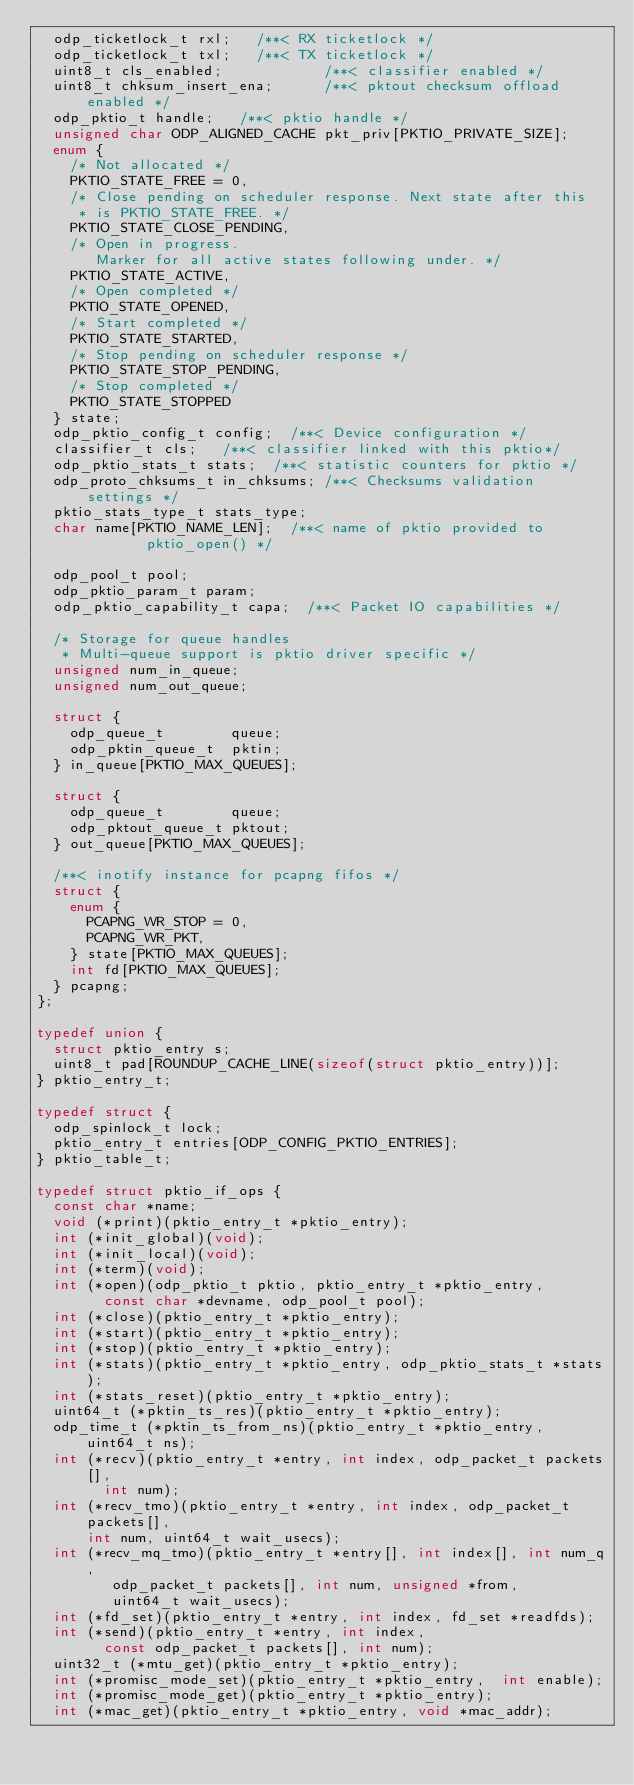<code> <loc_0><loc_0><loc_500><loc_500><_C_>	odp_ticketlock_t rxl;		/**< RX ticketlock */
	odp_ticketlock_t txl;		/**< TX ticketlock */
	uint8_t cls_enabled;            /**< classifier enabled */
	uint8_t chksum_insert_ena;      /**< pktout checksum offload enabled */
	odp_pktio_t handle;		/**< pktio handle */
	unsigned char ODP_ALIGNED_CACHE pkt_priv[PKTIO_PRIVATE_SIZE];
	enum {
		/* Not allocated */
		PKTIO_STATE_FREE = 0,
		/* Close pending on scheduler response. Next state after this
		 * is PKTIO_STATE_FREE. */
		PKTIO_STATE_CLOSE_PENDING,
		/* Open in progress.
		   Marker for all active states following under. */
		PKTIO_STATE_ACTIVE,
		/* Open completed */
		PKTIO_STATE_OPENED,
		/* Start completed */
		PKTIO_STATE_STARTED,
		/* Stop pending on scheduler response */
		PKTIO_STATE_STOP_PENDING,
		/* Stop completed */
		PKTIO_STATE_STOPPED
	} state;
	odp_pktio_config_t config;	/**< Device configuration */
	classifier_t cls;		/**< classifier linked with this pktio*/
	odp_pktio_stats_t stats;	/**< statistic counters for pktio */
	odp_proto_chksums_t in_chksums; /**< Checksums validation settings */
	pktio_stats_type_t stats_type;
	char name[PKTIO_NAME_LEN];	/**< name of pktio provided to
					   pktio_open() */

	odp_pool_t pool;
	odp_pktio_param_t param;
	odp_pktio_capability_t capa;	/**< Packet IO capabilities */

	/* Storage for queue handles
	 * Multi-queue support is pktio driver specific */
	unsigned num_in_queue;
	unsigned num_out_queue;

	struct {
		odp_queue_t        queue;
		odp_pktin_queue_t  pktin;
	} in_queue[PKTIO_MAX_QUEUES];

	struct {
		odp_queue_t        queue;
		odp_pktout_queue_t pktout;
	} out_queue[PKTIO_MAX_QUEUES];

	/**< inotify instance for pcapng fifos */
	struct {
		enum {
			PCAPNG_WR_STOP = 0,
			PCAPNG_WR_PKT,
		} state[PKTIO_MAX_QUEUES];
		int fd[PKTIO_MAX_QUEUES];
	} pcapng;
};

typedef union {
	struct pktio_entry s;
	uint8_t pad[ROUNDUP_CACHE_LINE(sizeof(struct pktio_entry))];
} pktio_entry_t;

typedef struct {
	odp_spinlock_t lock;
	pktio_entry_t entries[ODP_CONFIG_PKTIO_ENTRIES];
} pktio_table_t;

typedef struct pktio_if_ops {
	const char *name;
	void (*print)(pktio_entry_t *pktio_entry);
	int (*init_global)(void);
	int (*init_local)(void);
	int (*term)(void);
	int (*open)(odp_pktio_t pktio, pktio_entry_t *pktio_entry,
		    const char *devname, odp_pool_t pool);
	int (*close)(pktio_entry_t *pktio_entry);
	int (*start)(pktio_entry_t *pktio_entry);
	int (*stop)(pktio_entry_t *pktio_entry);
	int (*stats)(pktio_entry_t *pktio_entry, odp_pktio_stats_t *stats);
	int (*stats_reset)(pktio_entry_t *pktio_entry);
	uint64_t (*pktin_ts_res)(pktio_entry_t *pktio_entry);
	odp_time_t (*pktin_ts_from_ns)(pktio_entry_t *pktio_entry, uint64_t ns);
	int (*recv)(pktio_entry_t *entry, int index, odp_packet_t packets[],
		    int num);
	int (*recv_tmo)(pktio_entry_t *entry, int index, odp_packet_t packets[],
			int num, uint64_t wait_usecs);
	int (*recv_mq_tmo)(pktio_entry_t *entry[], int index[], int num_q,
			   odp_packet_t packets[], int num, unsigned *from,
			   uint64_t wait_usecs);
	int (*fd_set)(pktio_entry_t *entry, int index, fd_set *readfds);
	int (*send)(pktio_entry_t *entry, int index,
		    const odp_packet_t packets[], int num);
	uint32_t (*mtu_get)(pktio_entry_t *pktio_entry);
	int (*promisc_mode_set)(pktio_entry_t *pktio_entry,  int enable);
	int (*promisc_mode_get)(pktio_entry_t *pktio_entry);
	int (*mac_get)(pktio_entry_t *pktio_entry, void *mac_addr);</code> 